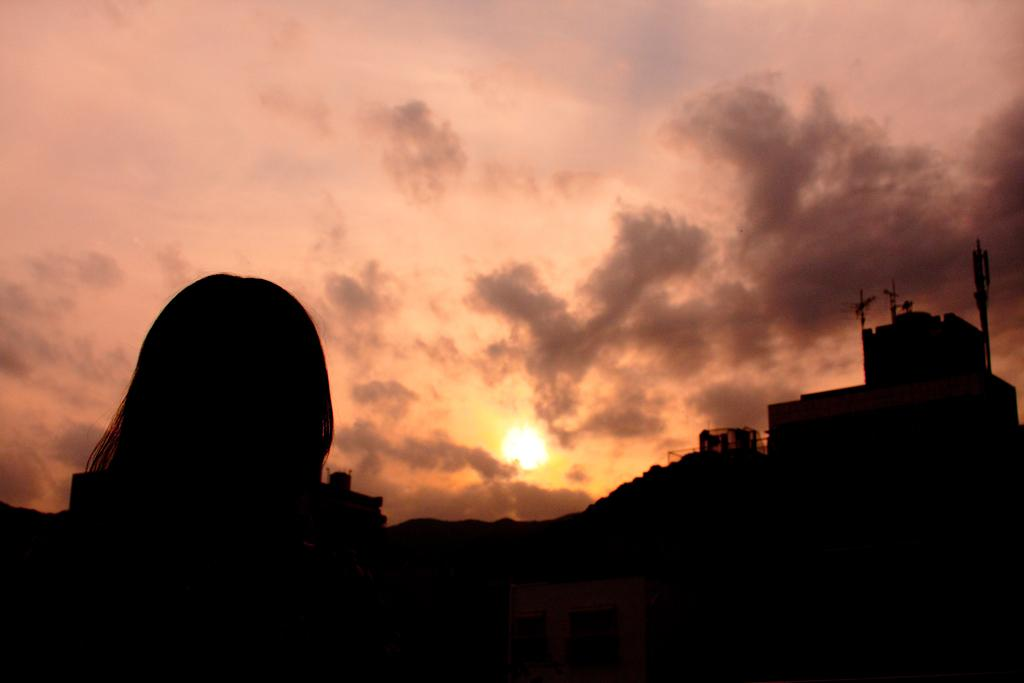What is located in the foreground of the image? There is a person in the foreground of the image. What type of structures can be seen in the image? There are houses and buildings in the image. What natural feature is visible in the image? There are mountains in the image. What is visible in the background of the image? The sky is visible in the background of the image. Can the sun be seen in the image? Yes, the sun is observable in the sky. What type of patch can be seen on the person's clothing in the image? There is no patch visible on the person's clothing in the image. How much salt is present on the mountains in the image? There is no salt present on the mountains in the image; it is a natural feature with no reference to salt. 